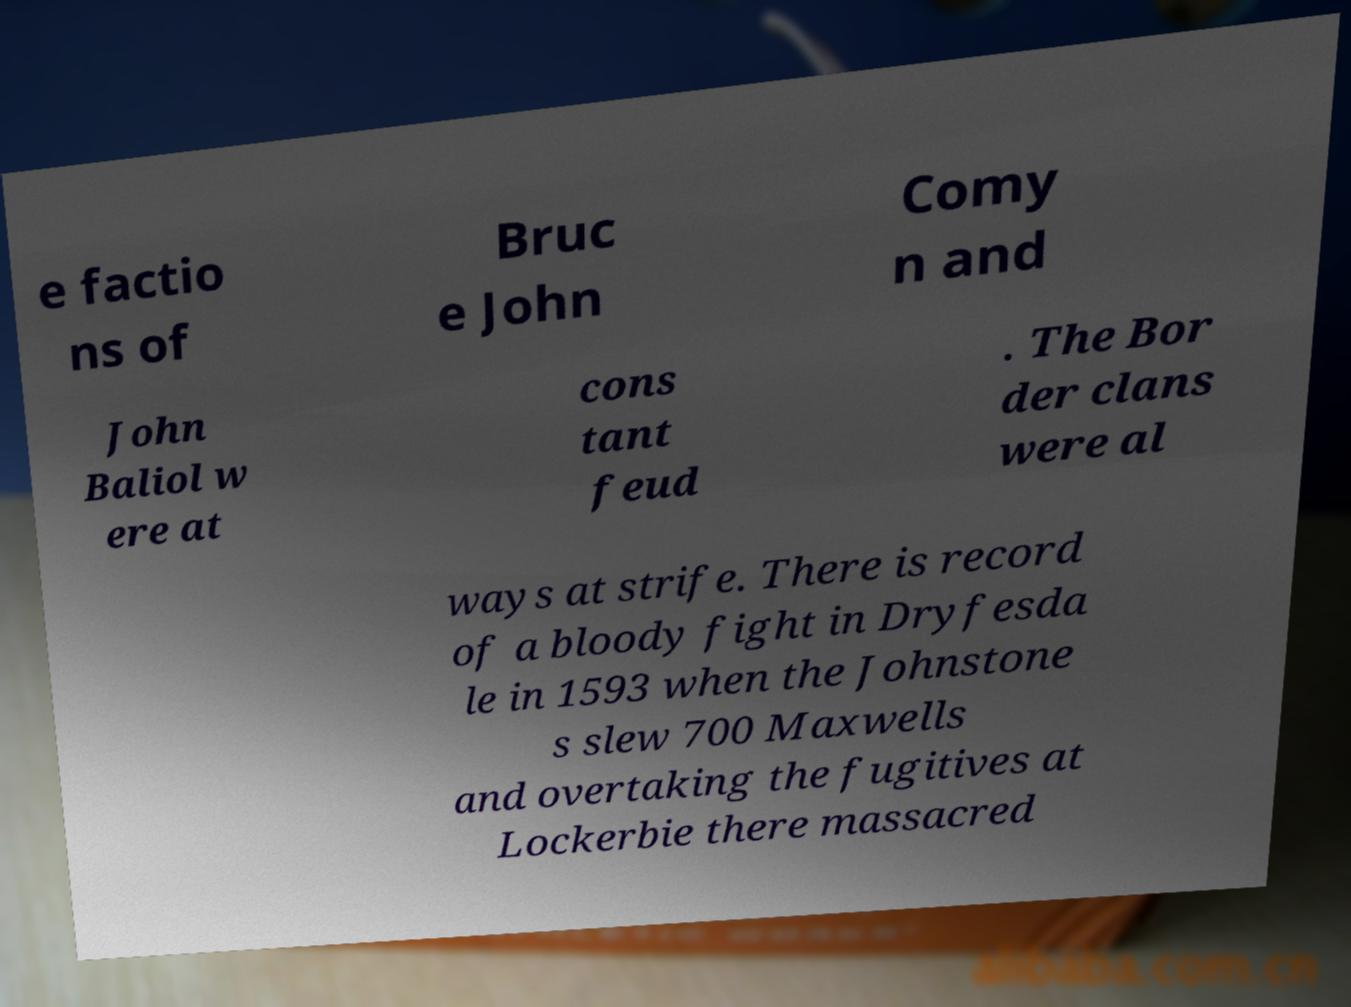Please identify and transcribe the text found in this image. e factio ns of Bruc e John Comy n and John Baliol w ere at cons tant feud . The Bor der clans were al ways at strife. There is record of a bloody fight in Dryfesda le in 1593 when the Johnstone s slew 700 Maxwells and overtaking the fugitives at Lockerbie there massacred 